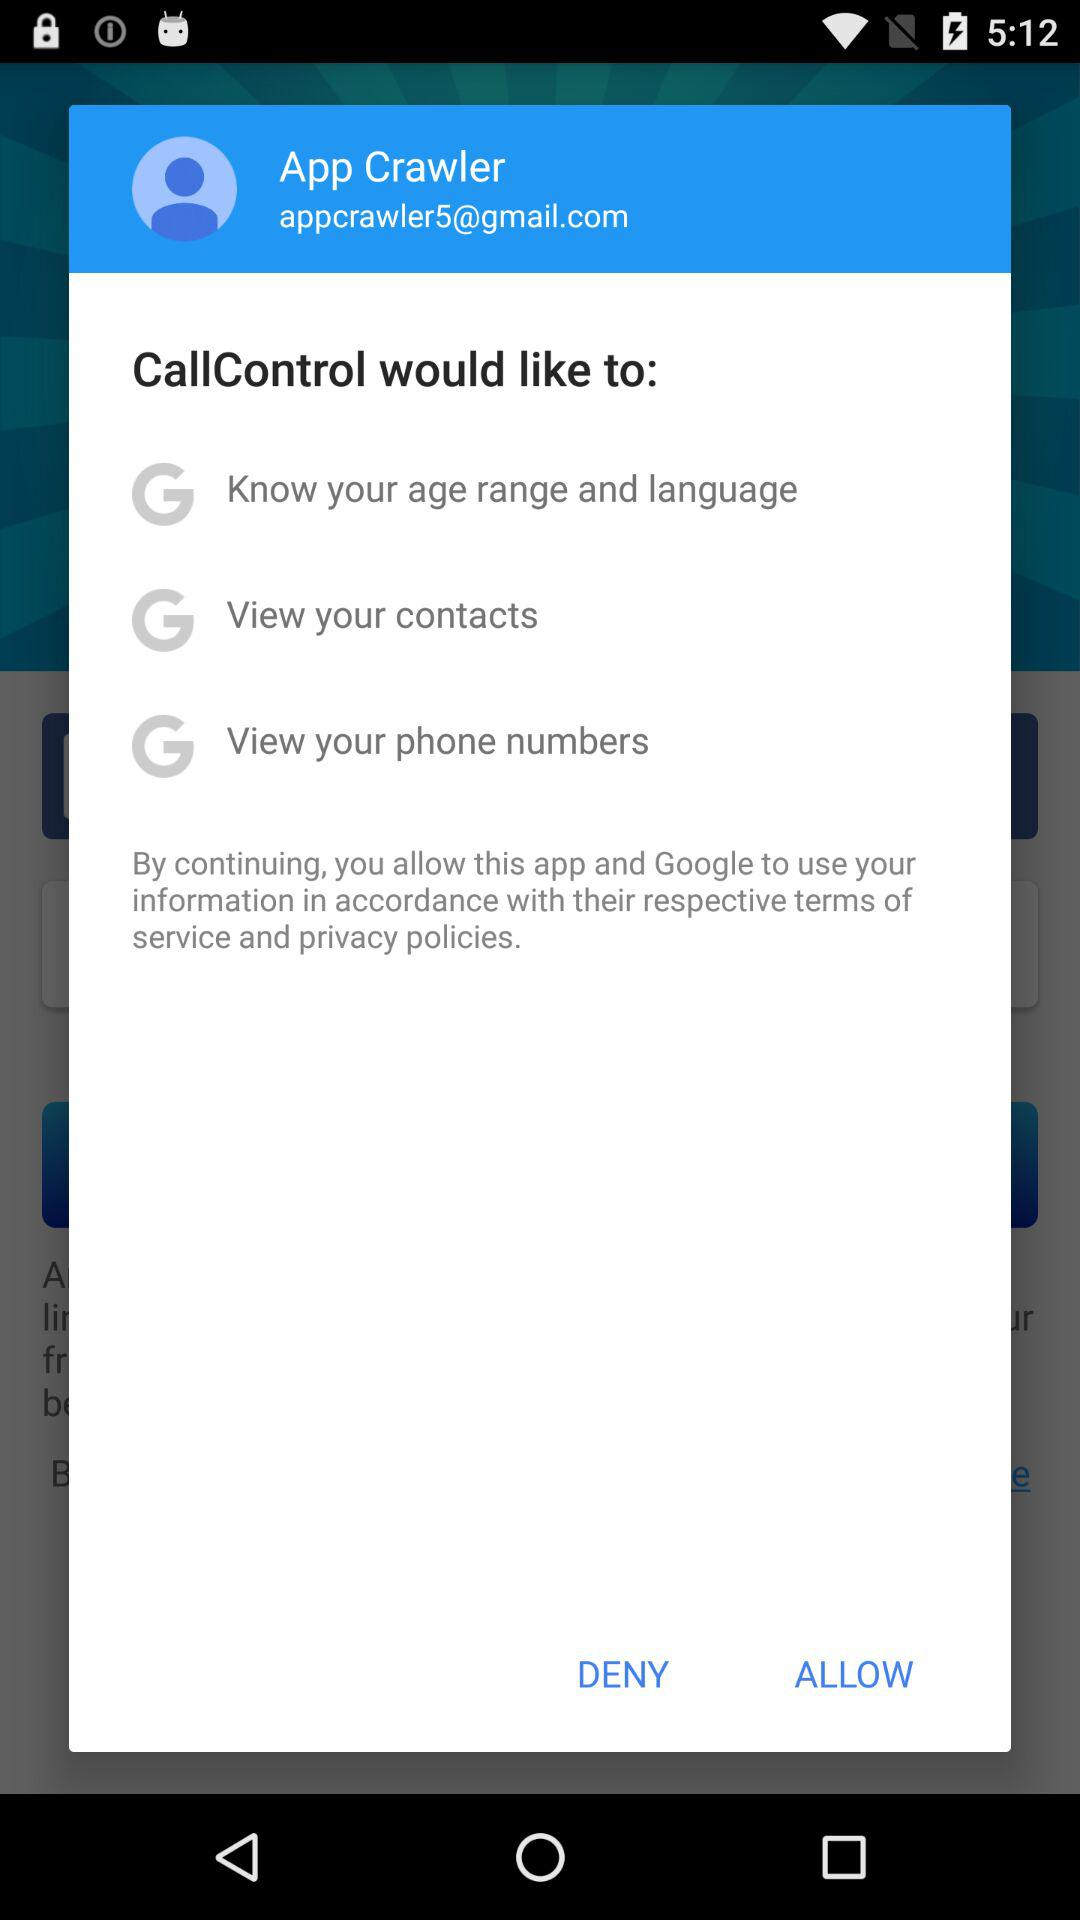How many permissions are being requested?
Answer the question using a single word or phrase. 3 